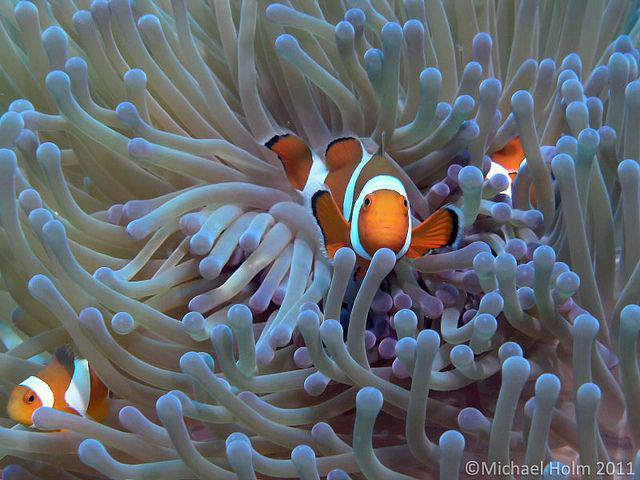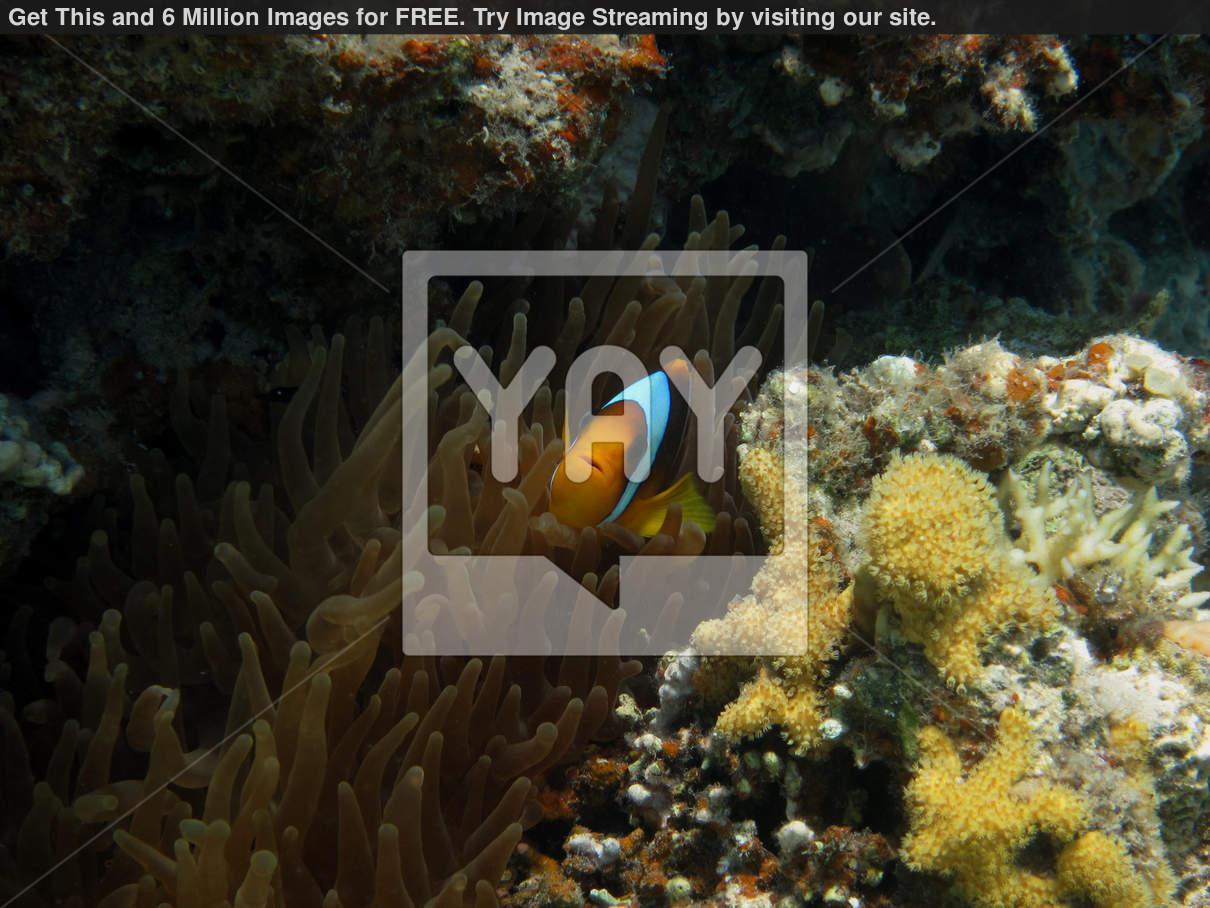The first image is the image on the left, the second image is the image on the right. For the images shown, is this caption "The left and right image contains the same number of fish." true? Answer yes or no. No. The first image is the image on the left, the second image is the image on the right. Considering the images on both sides, is "Several fish swim around the anemone in the image on the left, while a single fish swims in the image on the right." valid? Answer yes or no. Yes. 